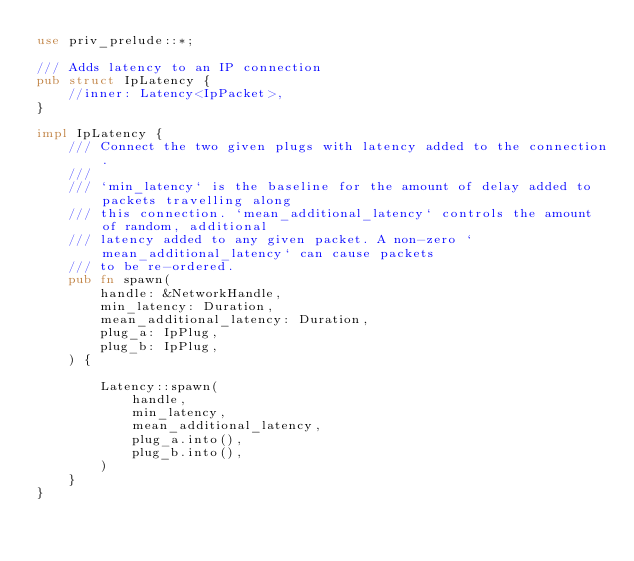<code> <loc_0><loc_0><loc_500><loc_500><_Rust_>use priv_prelude::*;

/// Adds latency to an IP connection
pub struct IpLatency {
    //inner: Latency<IpPacket>,
}

impl IpLatency {
    /// Connect the two given plugs with latency added to the connection.
    ///
    /// `min_latency` is the baseline for the amount of delay added to packets travelling along
    /// this connection. `mean_additional_latency` controls the amount of random, additional
    /// latency added to any given packet. A non-zero `mean_additional_latency` can cause packets
    /// to be re-ordered.
    pub fn spawn(
        handle: &NetworkHandle,
        min_latency: Duration,
        mean_additional_latency: Duration,
        plug_a: IpPlug,
        plug_b: IpPlug,
    ) {

        Latency::spawn(
            handle,
            min_latency,
            mean_additional_latency,
            plug_a.into(),
            plug_b.into(),
        )
    }
}

</code> 